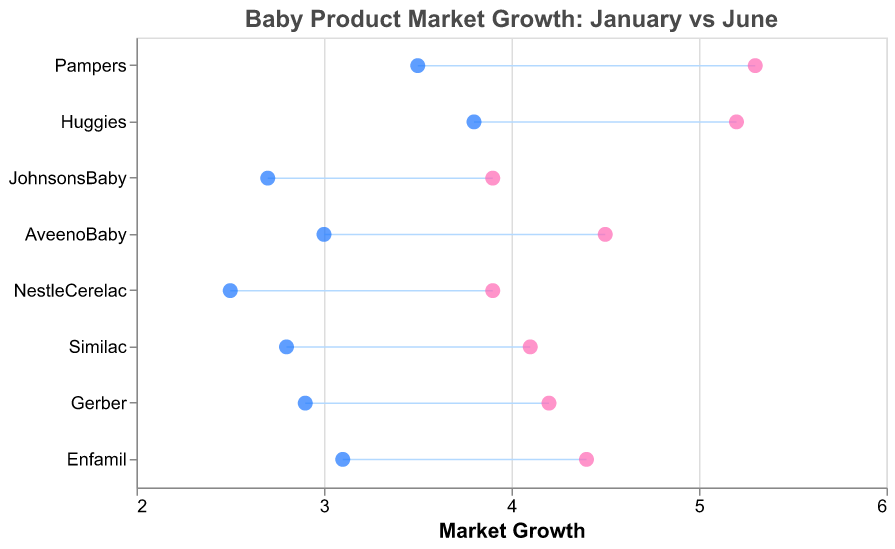What is the title of the figure? The title of the figure is displayed prominently at the top of the plot. It gives context to the data being represented.
Answer: Baby Product Market Growth: January vs June Which brand had the highest growth in June? By looking at the points on the right side (June) of the dumbbell plot, the brand with the highest value represents the highest growth.
Answer: Pampers How much did the market for Pampers grow from January to June? Find Pampers on the y-axis, then measure the distance between the January and June points on the x-axis to get the growth.
Answer: 1.8 Which brand has the smallest growth from January to June? Compare the length of the lines (representing the growth) for each brand; the brand with the shortest line has the smallest growth.
Answer: JohnsonsBaby Compare the market growth of Huggies and Enfamil between January and June. Which one grew more? Look at the January and June points for both brands; calculate the difference between January and June for each brand and compare the results.
Answer: Huggies grew more What is the color of the points representing the data for January? Observing the color of the points located on the left side of each line which represent January.
Answer: Blue What is the difference in growth between Gerber and Similac from January to June? Calculate the growth for each brand by subtracting the January value from the June value for both brands and then take the difference.
Answer: 0.2 Which brand had the closest market growth in January to its growth in June? Look for the brand with the shortest distance between the January and June points.
Answer: JohnsonsBaby What is the average market growth of NestleCerelac from January to June? Obtain the values for January and June for NestleCerelac, then calculate their average: (2.5 + 3.9) / 2.
Answer: 3.2 Which two brands showed almost similar growth trends from January to June? Look for the dumbbell plots that have nearly the same length and position along the x-axis from January to June.
Answer: Gerber and Similac 